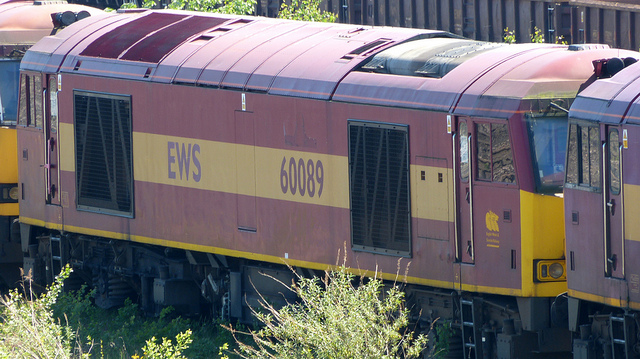Extract all visible text content from this image. EWS 60089 